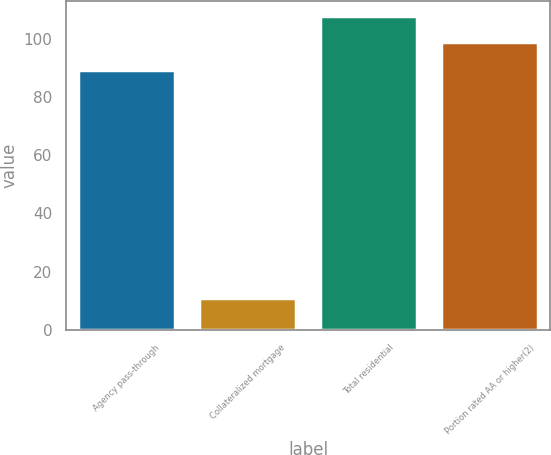Convert chart. <chart><loc_0><loc_0><loc_500><loc_500><bar_chart><fcel>Agency pass-through<fcel>Collateralized mortgage<fcel>Total residential<fcel>Portion rated AA or higher(2)<nl><fcel>89.1<fcel>10.9<fcel>107.61<fcel>98.7<nl></chart> 